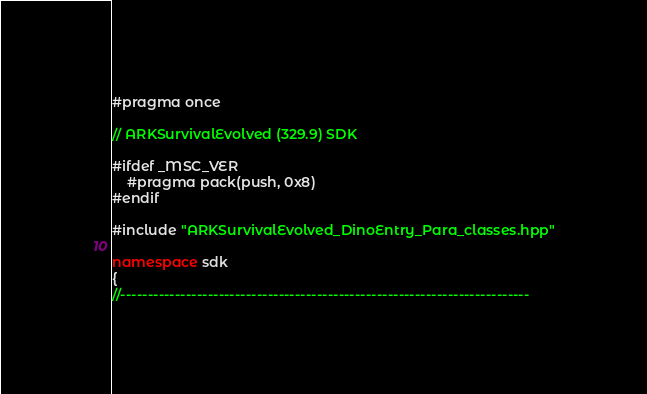Convert code to text. <code><loc_0><loc_0><loc_500><loc_500><_C++_>#pragma once

// ARKSurvivalEvolved (329.9) SDK

#ifdef _MSC_VER
	#pragma pack(push, 0x8)
#endif

#include "ARKSurvivalEvolved_DinoEntry_Para_classes.hpp"

namespace sdk
{
//---------------------------------------------------------------------------</code> 